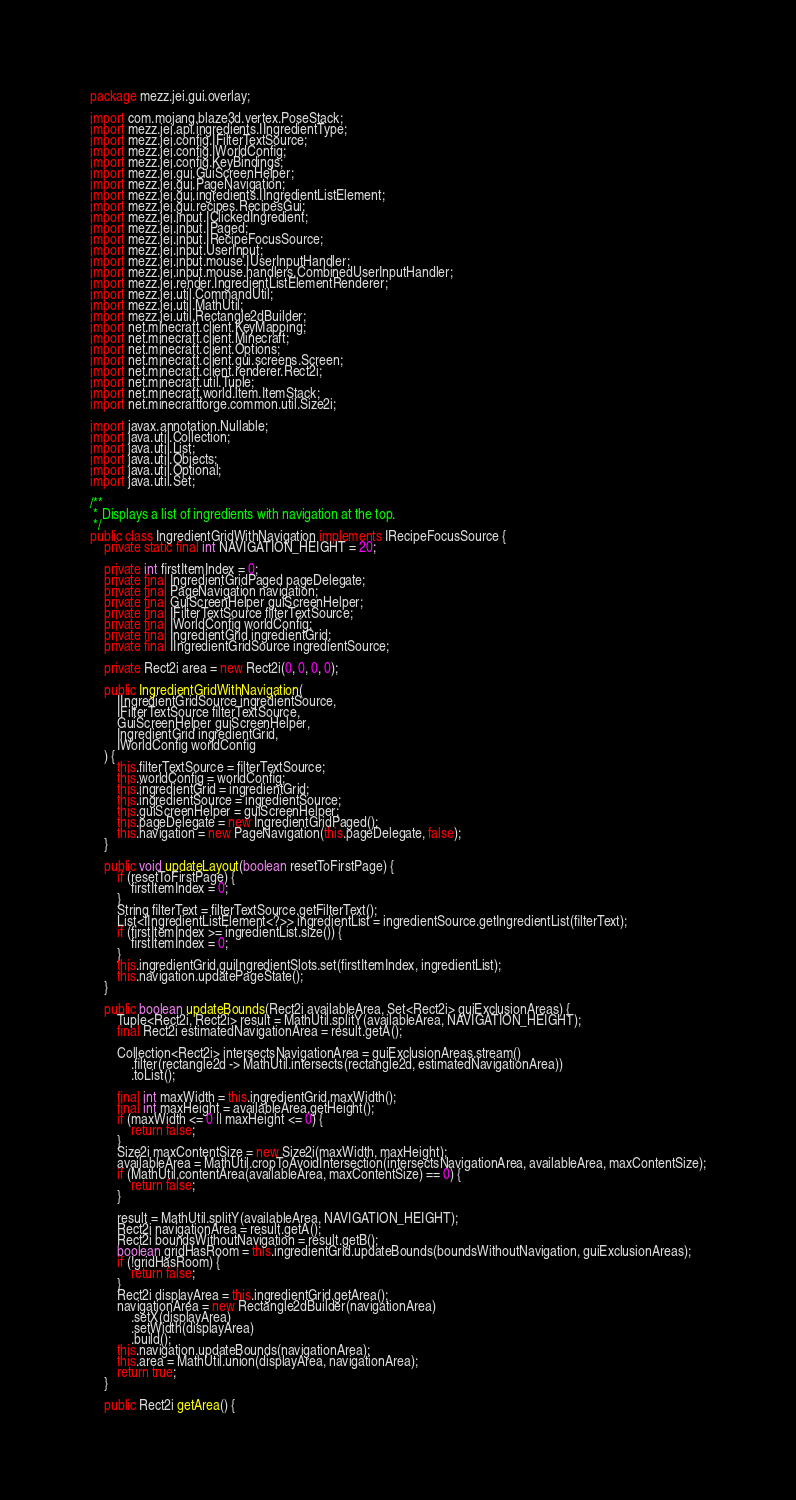<code> <loc_0><loc_0><loc_500><loc_500><_Java_>package mezz.jei.gui.overlay;

import com.mojang.blaze3d.vertex.PoseStack;
import mezz.jei.api.ingredients.IIngredientType;
import mezz.jei.config.IFilterTextSource;
import mezz.jei.config.IWorldConfig;
import mezz.jei.config.KeyBindings;
import mezz.jei.gui.GuiScreenHelper;
import mezz.jei.gui.PageNavigation;
import mezz.jei.gui.ingredients.IIngredientListElement;
import mezz.jei.gui.recipes.RecipesGui;
import mezz.jei.input.IClickedIngredient;
import mezz.jei.input.IPaged;
import mezz.jei.input.IRecipeFocusSource;
import mezz.jei.input.UserInput;
import mezz.jei.input.mouse.IUserInputHandler;
import mezz.jei.input.mouse.handlers.CombinedUserInputHandler;
import mezz.jei.render.IngredientListElementRenderer;
import mezz.jei.util.CommandUtil;
import mezz.jei.util.MathUtil;
import mezz.jei.util.Rectangle2dBuilder;
import net.minecraft.client.KeyMapping;
import net.minecraft.client.Minecraft;
import net.minecraft.client.Options;
import net.minecraft.client.gui.screens.Screen;
import net.minecraft.client.renderer.Rect2i;
import net.minecraft.util.Tuple;
import net.minecraft.world.item.ItemStack;
import net.minecraftforge.common.util.Size2i;

import javax.annotation.Nullable;
import java.util.Collection;
import java.util.List;
import java.util.Objects;
import java.util.Optional;
import java.util.Set;

/**
 * Displays a list of ingredients with navigation at the top.
 */
public class IngredientGridWithNavigation implements IRecipeFocusSource {
	private static final int NAVIGATION_HEIGHT = 20;

	private int firstItemIndex = 0;
	private final IngredientGridPaged pageDelegate;
	private final PageNavigation navigation;
	private final GuiScreenHelper guiScreenHelper;
	private final IFilterTextSource filterTextSource;
	private final IWorldConfig worldConfig;
	private final IngredientGrid ingredientGrid;
	private final IIngredientGridSource ingredientSource;

	private Rect2i area = new Rect2i(0, 0, 0, 0);

	public IngredientGridWithNavigation(
		IIngredientGridSource ingredientSource,
		IFilterTextSource filterTextSource,
		GuiScreenHelper guiScreenHelper,
		IngredientGrid ingredientGrid,
		IWorldConfig worldConfig
	) {
		this.filterTextSource = filterTextSource;
		this.worldConfig = worldConfig;
		this.ingredientGrid = ingredientGrid;
		this.ingredientSource = ingredientSource;
		this.guiScreenHelper = guiScreenHelper;
		this.pageDelegate = new IngredientGridPaged();
		this.navigation = new PageNavigation(this.pageDelegate, false);
	}

	public void updateLayout(boolean resetToFirstPage) {
		if (resetToFirstPage) {
			firstItemIndex = 0;
		}
		String filterText = filterTextSource.getFilterText();
		List<IIngredientListElement<?>> ingredientList = ingredientSource.getIngredientList(filterText);
		if (firstItemIndex >= ingredientList.size()) {
			firstItemIndex = 0;
		}
		this.ingredientGrid.guiIngredientSlots.set(firstItemIndex, ingredientList);
		this.navigation.updatePageState();
	}

	public boolean updateBounds(Rect2i availableArea, Set<Rect2i> guiExclusionAreas) {
		Tuple<Rect2i, Rect2i> result = MathUtil.splitY(availableArea, NAVIGATION_HEIGHT);
		final Rect2i estimatedNavigationArea = result.getA();

		Collection<Rect2i> intersectsNavigationArea = guiExclusionAreas.stream()
			.filter(rectangle2d -> MathUtil.intersects(rectangle2d, estimatedNavigationArea))
			.toList();

		final int maxWidth = this.ingredientGrid.maxWidth();
		final int maxHeight = availableArea.getHeight();
		if (maxWidth <= 0 || maxHeight <= 0) {
			return false;
		}
		Size2i maxContentSize = new Size2i(maxWidth, maxHeight);
		availableArea = MathUtil.cropToAvoidIntersection(intersectsNavigationArea, availableArea, maxContentSize);
		if (MathUtil.contentArea(availableArea, maxContentSize) == 0) {
			return false;
		}

		result = MathUtil.splitY(availableArea, NAVIGATION_HEIGHT);
		Rect2i navigationArea = result.getA();
		Rect2i boundsWithoutNavigation = result.getB();
		boolean gridHasRoom = this.ingredientGrid.updateBounds(boundsWithoutNavigation, guiExclusionAreas);
		if (!gridHasRoom) {
			return false;
		}
		Rect2i displayArea = this.ingredientGrid.getArea();
		navigationArea = new Rectangle2dBuilder(navigationArea)
			.setX(displayArea)
			.setWidth(displayArea)
			.build();
		this.navigation.updateBounds(navigationArea);
		this.area = MathUtil.union(displayArea, navigationArea);
		return true;
	}

	public Rect2i getArea() {</code> 